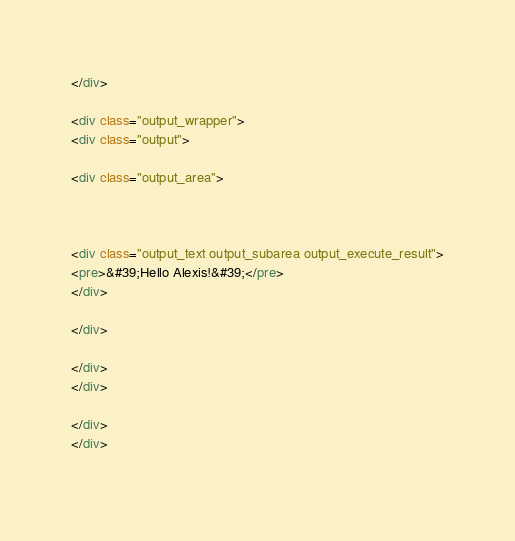<code> <loc_0><loc_0><loc_500><loc_500><_HTML_></div>

<div class="output_wrapper">
<div class="output">

<div class="output_area">



<div class="output_text output_subarea output_execute_result">
<pre>&#39;Hello Alexis!&#39;</pre>
</div>

</div>

</div>
</div>

</div>
</div>
 

</code> 